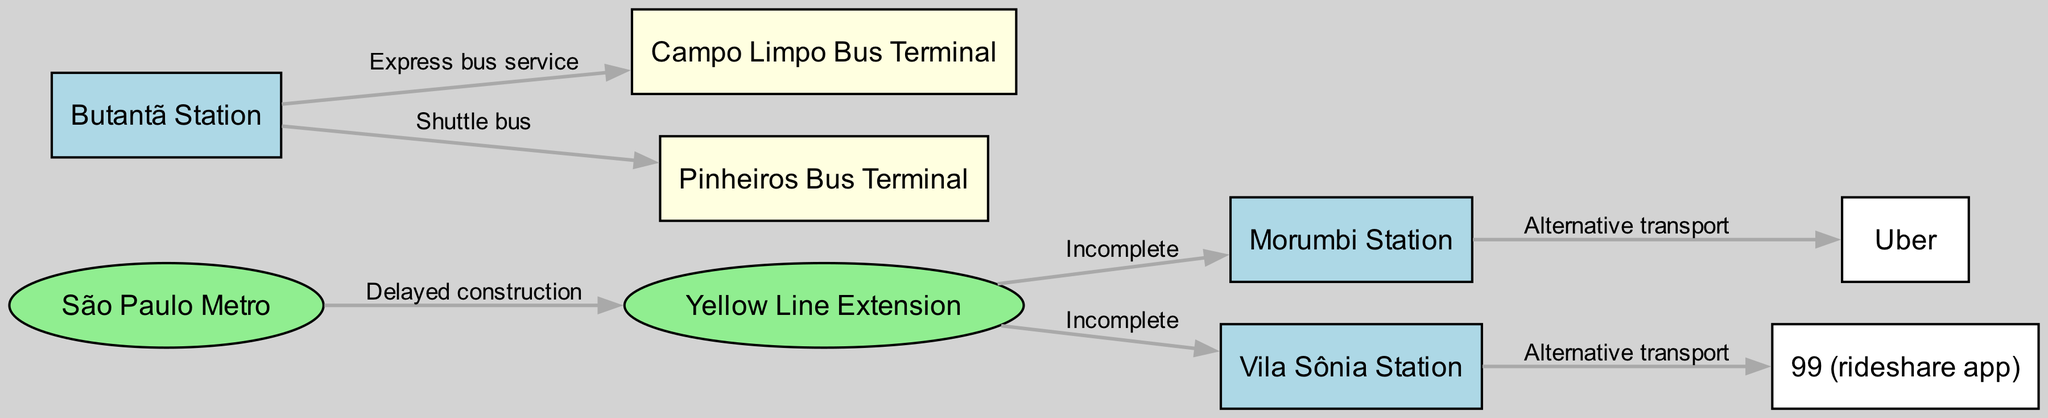What are the two stations connected by the yellow line extension? According to the edge labels in the diagram, the Yellow Line Extension is connected to two stations: Morumbi Station and Vila Sônia Station.
Answer: Morumbi Station, Vila Sônia Station How many nodes are there in the diagram? By counting the unique nodes listed in the data, the total number of nodes is nine: São Paulo Metro, Morumbi Station, Vila Sônia Station, Butantã Station, Campo Limpo Bus Terminal, Pinheiros Bus Terminal, Uber, 99 (rideshare app), and Yellow Line Extension.
Answer: 9 What transport options are categorized as alternative transport? The diagram indicates that Uber and 99 (rideshare app) are both labeled as alternative transport, specifically linked to Morumbi Station and Vila Sônia Station, respectively.
Answer: Uber, 99 (rideshare app) What type of service connects Butantã Station to Campo Limpo Bus Terminal? The edge between Butantã Station and Campo Limpo Bus Terminal is labeled as an express bus service, indicating a direct connection for efficient travel between these two nodes.
Answer: Express bus service Which station is linked by a shuttle bus service? The edge label suggests that the Butantã Station is connected to the Pinheiros Bus Terminal by a shuttle bus, making it a critical transit point in the network.
Answer: Pinheiros Bus Terminal What is the main reason the Yellow Line Extension is significant in this diagram? The Yellow Line Extension is pivotal due to its delayed construction, which directly affects access to the connecting stations of Morumbi and Vila Sônia as indicated.
Answer: Delayed construction Which bus terminal does Butantã Station connect with via an express service? The connection from Butantã Station leads directly to Campo Limpo Bus Terminal as indicated by the edge's label describing it as an express bus service.
Answer: Campo Limpo Bus Terminal How do riders reach Morumbi Station if they choose alternative transportation? Riders can utilize Uber as an alternative mode of transport to reach Morumbi Station, which is explicitly shown in the graph.
Answer: Uber 